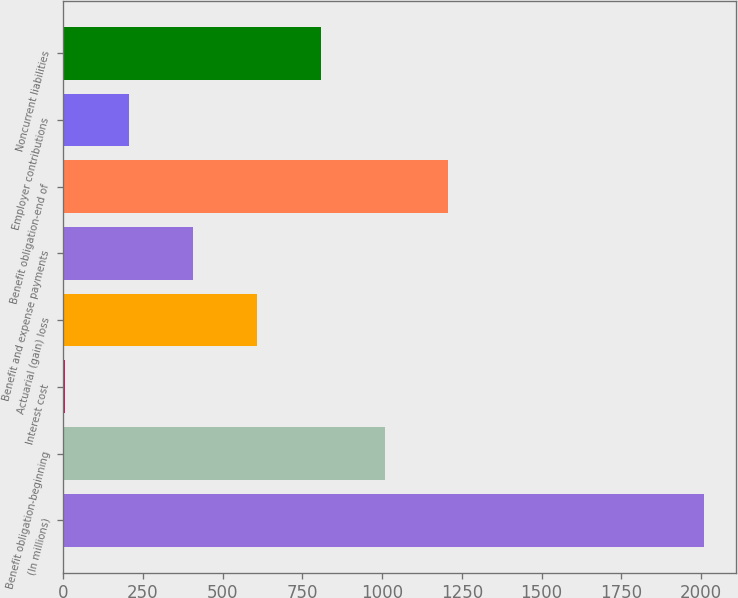Convert chart to OTSL. <chart><loc_0><loc_0><loc_500><loc_500><bar_chart><fcel>(In millions)<fcel>Benefit obligation-beginning<fcel>Interest cost<fcel>Actuarial (gain) loss<fcel>Benefit and expense payments<fcel>Benefit obligation-end of<fcel>Employer contributions<fcel>Noncurrent liabilities<nl><fcel>2010<fcel>1007.45<fcel>4.9<fcel>606.43<fcel>405.92<fcel>1207.96<fcel>205.41<fcel>806.94<nl></chart> 